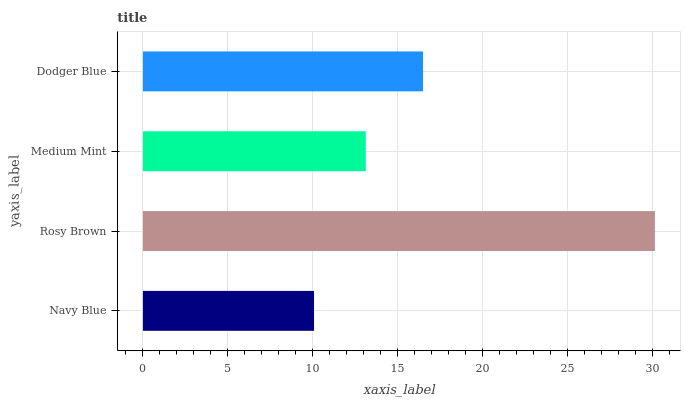Is Navy Blue the minimum?
Answer yes or no. Yes. Is Rosy Brown the maximum?
Answer yes or no. Yes. Is Medium Mint the minimum?
Answer yes or no. No. Is Medium Mint the maximum?
Answer yes or no. No. Is Rosy Brown greater than Medium Mint?
Answer yes or no. Yes. Is Medium Mint less than Rosy Brown?
Answer yes or no. Yes. Is Medium Mint greater than Rosy Brown?
Answer yes or no. No. Is Rosy Brown less than Medium Mint?
Answer yes or no. No. Is Dodger Blue the high median?
Answer yes or no. Yes. Is Medium Mint the low median?
Answer yes or no. Yes. Is Rosy Brown the high median?
Answer yes or no. No. Is Dodger Blue the low median?
Answer yes or no. No. 